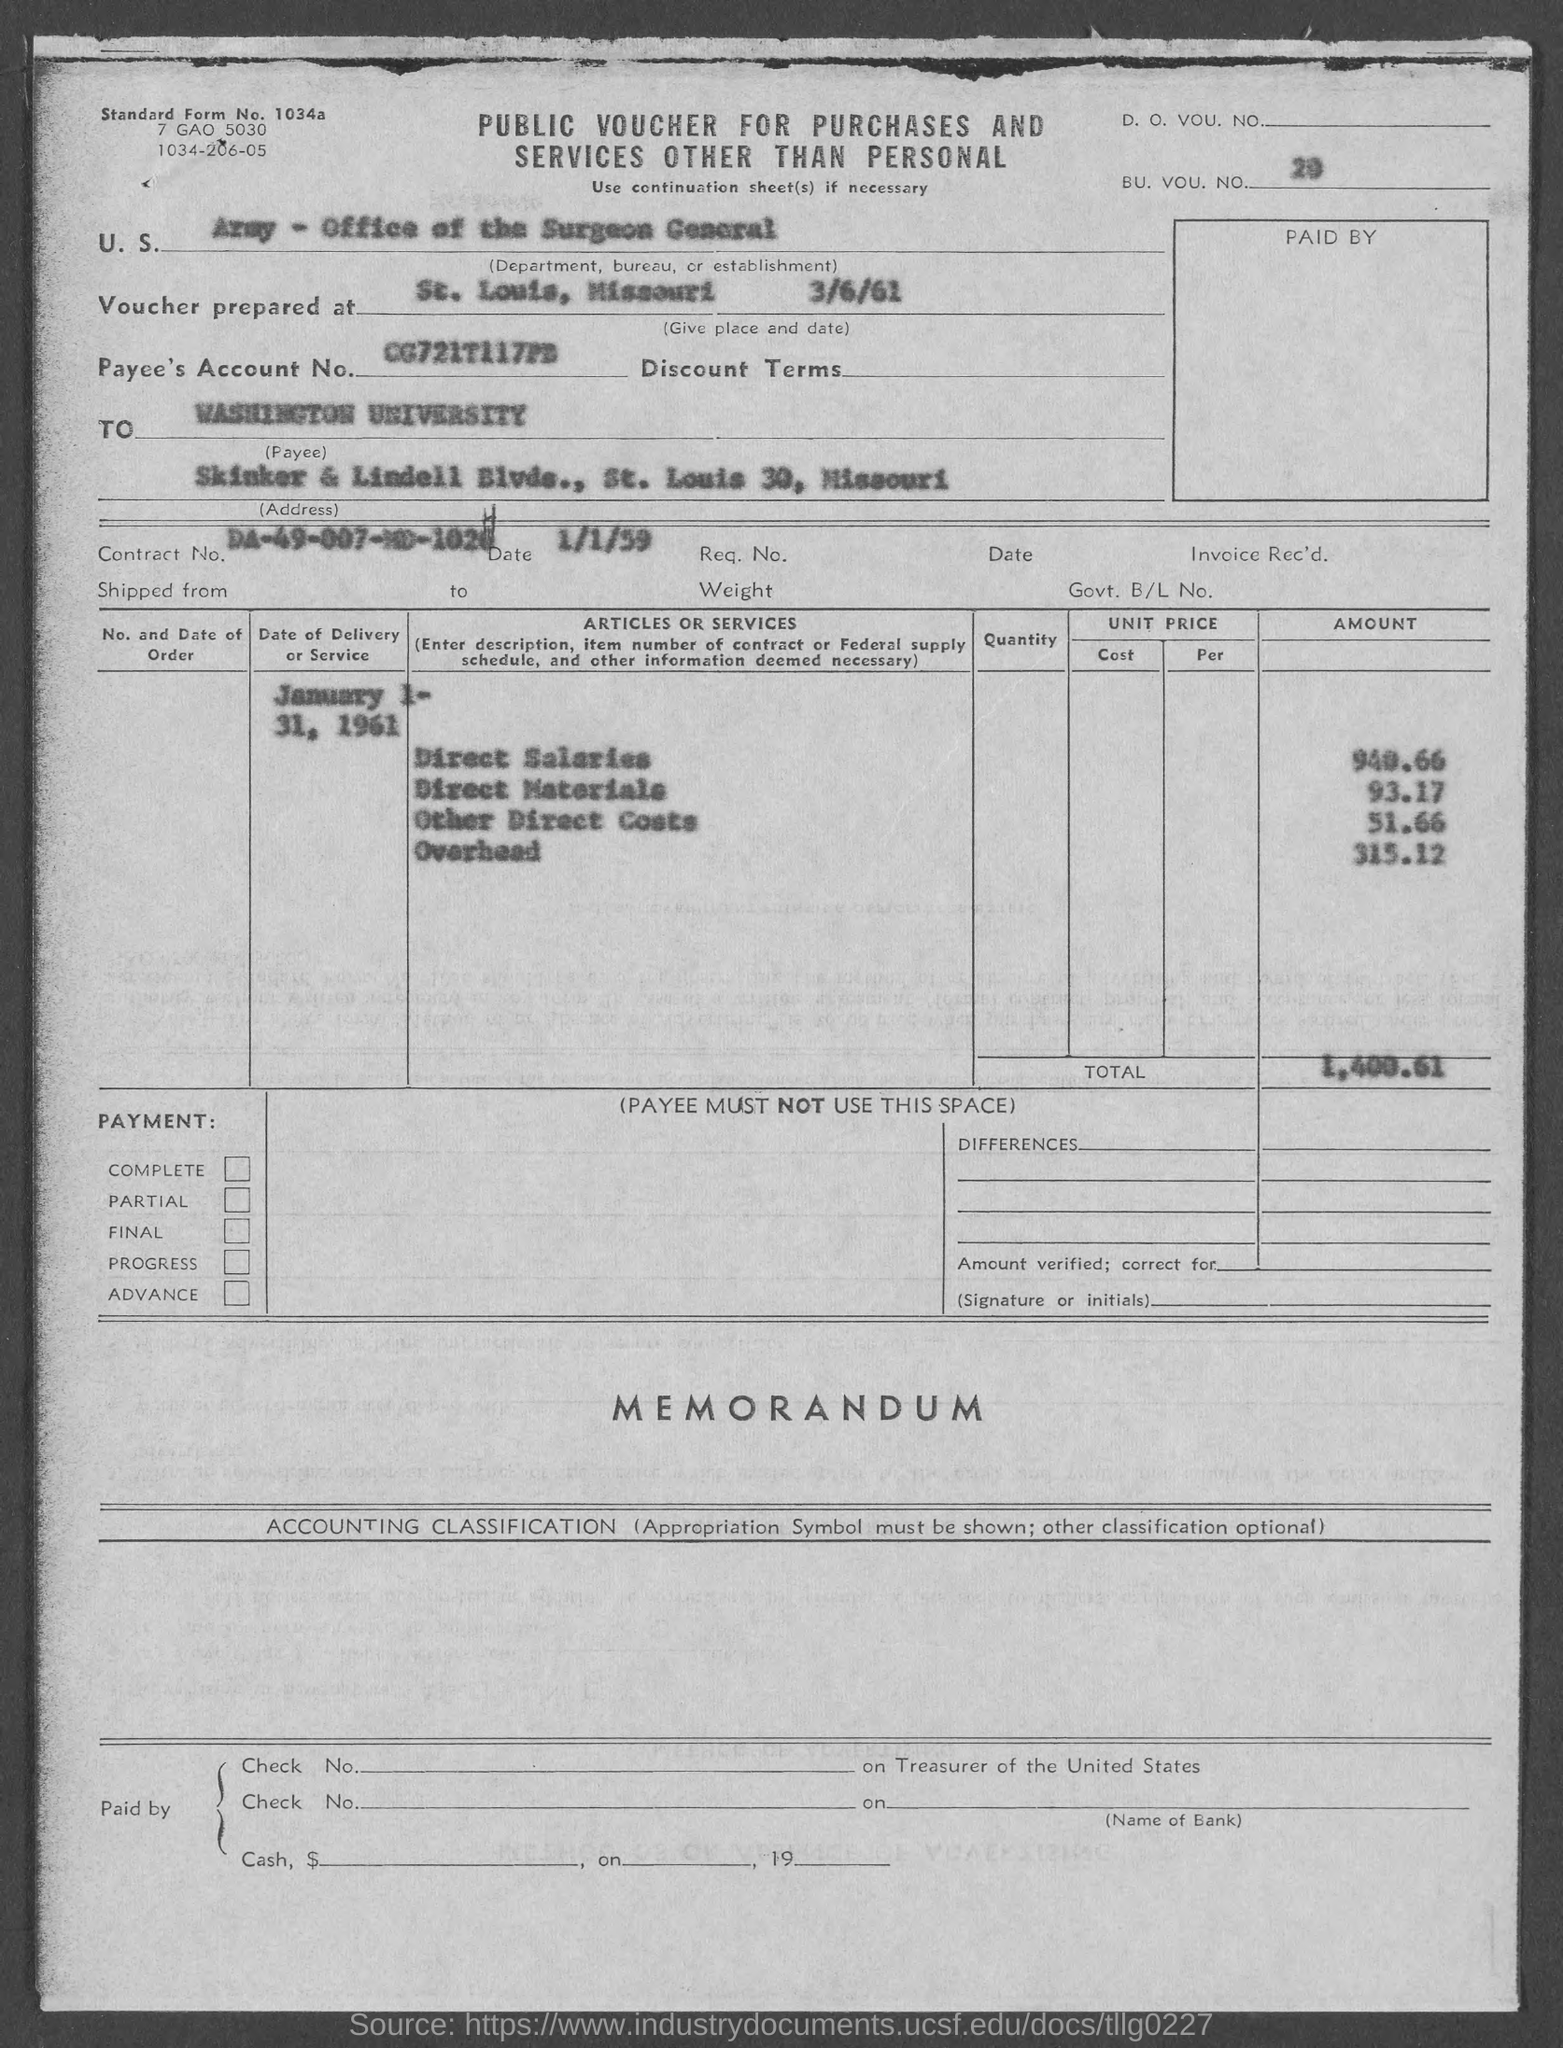What is the U.S. Department, Bureau, or Establishment given in the voucher?
Provide a succinct answer. ARMY - Office of the Surgeon General. What is the BU. VOU. NO. mentioned in the voucher?
Provide a succinct answer. 20. Where is the voucher prepared at?
Make the answer very short. St. Louis, Missouri. What is the Payee's Account No. given in the voucher?
Your answer should be compact. CG721T117PD. What is the Contract No. given in the voucher?
Your answer should be compact. DA-49-007-MD-1024. What is the date of contract given in the voucher?
Give a very brief answer. 1/1/59. What is the direct salaries cost mentioned in the voucher?
Make the answer very short. 940.66. What is the Direct materials cost given in the voucher?
Keep it short and to the point. 93.17. What is the overhead cost given in the voucher?
Keep it short and to the point. 315.12. What is the total voucher amount mentioned in the document?
Provide a short and direct response. 1,400.61. 